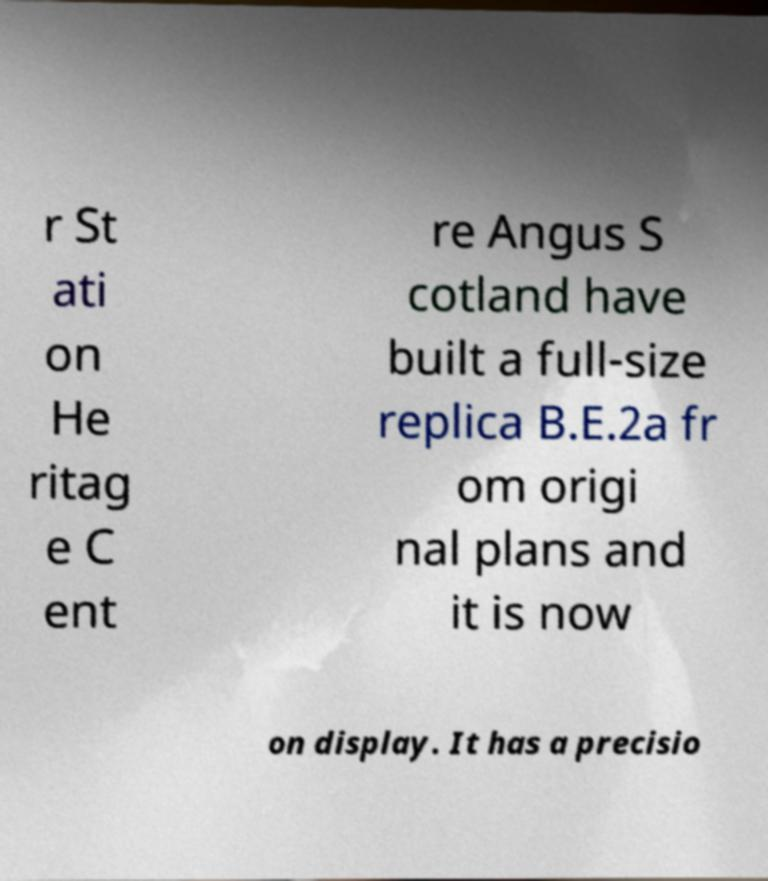Could you extract and type out the text from this image? r St ati on He ritag e C ent re Angus S cotland have built a full-size replica B.E.2a fr om origi nal plans and it is now on display. It has a precisio 